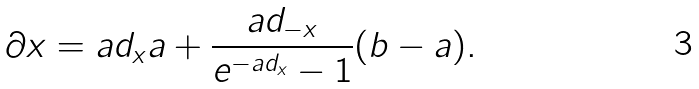<formula> <loc_0><loc_0><loc_500><loc_500>\partial x = a d _ { x } a + \frac { a d _ { - x } } { e ^ { - a d _ { x } } - 1 } ( b - a ) .</formula> 